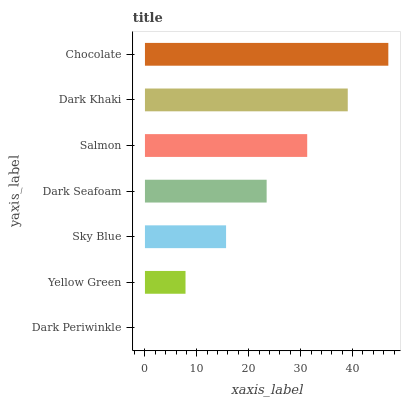Is Dark Periwinkle the minimum?
Answer yes or no. Yes. Is Chocolate the maximum?
Answer yes or no. Yes. Is Yellow Green the minimum?
Answer yes or no. No. Is Yellow Green the maximum?
Answer yes or no. No. Is Yellow Green greater than Dark Periwinkle?
Answer yes or no. Yes. Is Dark Periwinkle less than Yellow Green?
Answer yes or no. Yes. Is Dark Periwinkle greater than Yellow Green?
Answer yes or no. No. Is Yellow Green less than Dark Periwinkle?
Answer yes or no. No. Is Dark Seafoam the high median?
Answer yes or no. Yes. Is Dark Seafoam the low median?
Answer yes or no. Yes. Is Sky Blue the high median?
Answer yes or no. No. Is Sky Blue the low median?
Answer yes or no. No. 